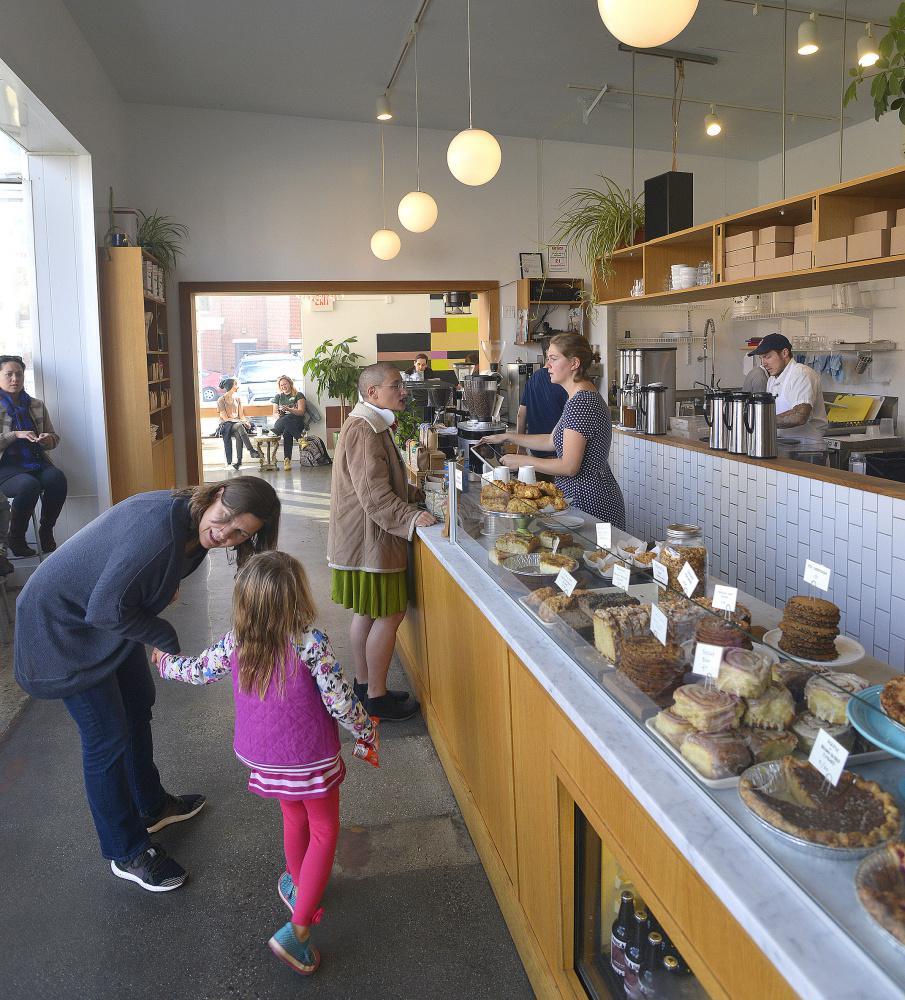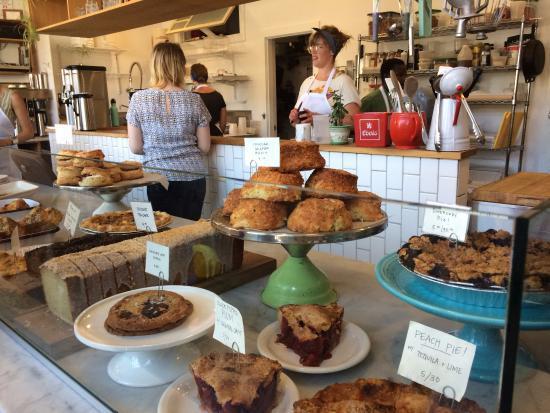The first image is the image on the left, the second image is the image on the right. Examine the images to the left and right. Is the description "There is a single green cake holder that contains  at least seven yellow and brown looking muffin tops." accurate? Answer yes or no. Yes. The first image is the image on the left, the second image is the image on the right. Evaluate the accuracy of this statement regarding the images: "Each image contains a person behind a counter.". Is it true? Answer yes or no. Yes. 